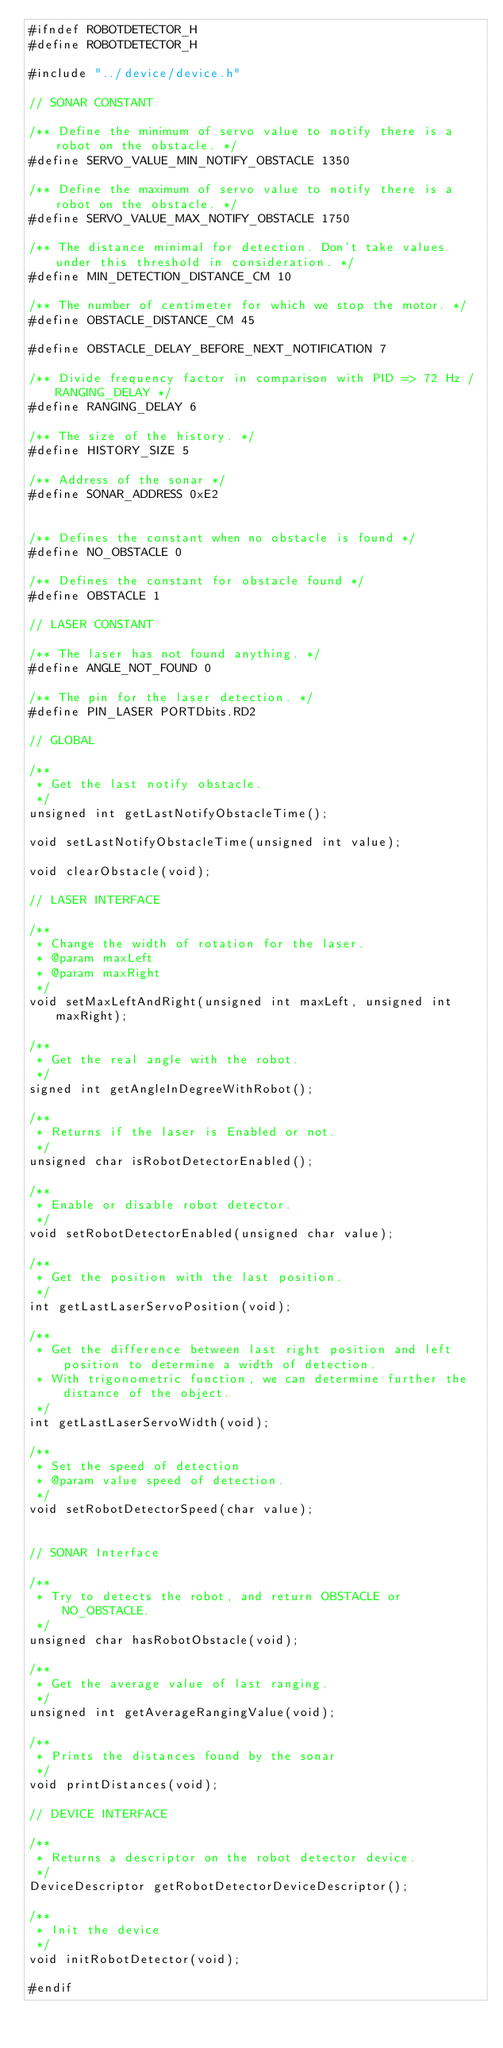Convert code to text. <code><loc_0><loc_0><loc_500><loc_500><_C_>#ifndef ROBOTDETECTOR_H
#define ROBOTDETECTOR_H

#include "../device/device.h"

// SONAR CONSTANT

/** Define the minimum of servo value to notify there is a robot on the obstacle. */
#define SERVO_VALUE_MIN_NOTIFY_OBSTACLE 1350

/** Define the maximum of servo value to notify there is a robot on the obstacle. */
#define SERVO_VALUE_MAX_NOTIFY_OBSTACLE 1750

/** The distance minimal for detection. Don't take values under this threshold in consideration. */
#define MIN_DETECTION_DISTANCE_CM 10

/** The number of centimeter for which we stop the motor. */
#define OBSTACLE_DISTANCE_CM 45

#define OBSTACLE_DELAY_BEFORE_NEXT_NOTIFICATION 7

/** Divide frequency factor in comparison with PID => 72 Hz / RANGING_DELAY */
#define RANGING_DELAY 6

/** The size of the history. */
#define HISTORY_SIZE 5

/** Address of the sonar */
#define SONAR_ADDRESS 0xE2


/** Defines the constant when no obstacle is found */
#define NO_OBSTACLE 0

/** Defines the constant for obstacle found */
#define OBSTACLE 1

// LASER CONSTANT

/** The laser has not found anything. */
#define ANGLE_NOT_FOUND 0

/** The pin for the laser detection. */
#define PIN_LASER PORTDbits.RD2

// GLOBAL

/**
 * Get the last notify obstacle.
 */
unsigned int getLastNotifyObstacleTime();

void setLastNotifyObstacleTime(unsigned int value);

void clearObstacle(void);

// LASER INTERFACE

/**
 * Change the width of rotation for the laser.
 * @param maxLeft 
 * @param maxRight
 */
void setMaxLeftAndRight(unsigned int maxLeft, unsigned int maxRight);

/**
 * Get the real angle with the robot.
 */
signed int getAngleInDegreeWithRobot();

/**
 * Returns if the laser is Enabled or not.
 */
unsigned char isRobotDetectorEnabled();

/**
 * Enable or disable robot detector.
 */
void setRobotDetectorEnabled(unsigned char value);

/**
 * Get the position with the last position.
 */
int getLastLaserServoPosition(void);

/**
 * Get the difference between last right position and left position to determine a width of detection.
 * With trigonometric function, we can determine further the distance of the object.
 */
int getLastLaserServoWidth(void);

/**
 * Set the speed of detection
 * @param value speed of detection.
 */
void setRobotDetectorSpeed(char value);


// SONAR Interface

/**
 * Try to detects the robot, and return OBSTACLE or NO_OBSTACLE.
 */
unsigned char hasRobotObstacle(void);

/**
 * Get the average value of last ranging.
 */
unsigned int getAverageRangingValue(void);

/**
 * Prints the distances found by the sonar
 */
void printDistances(void);

// DEVICE INTERFACE

/**
 * Returns a descriptor on the robot detector device.
 */
DeviceDescriptor getRobotDetectorDeviceDescriptor();

/**
 * Init the device
 */
void initRobotDetector(void);

#endif


</code> 